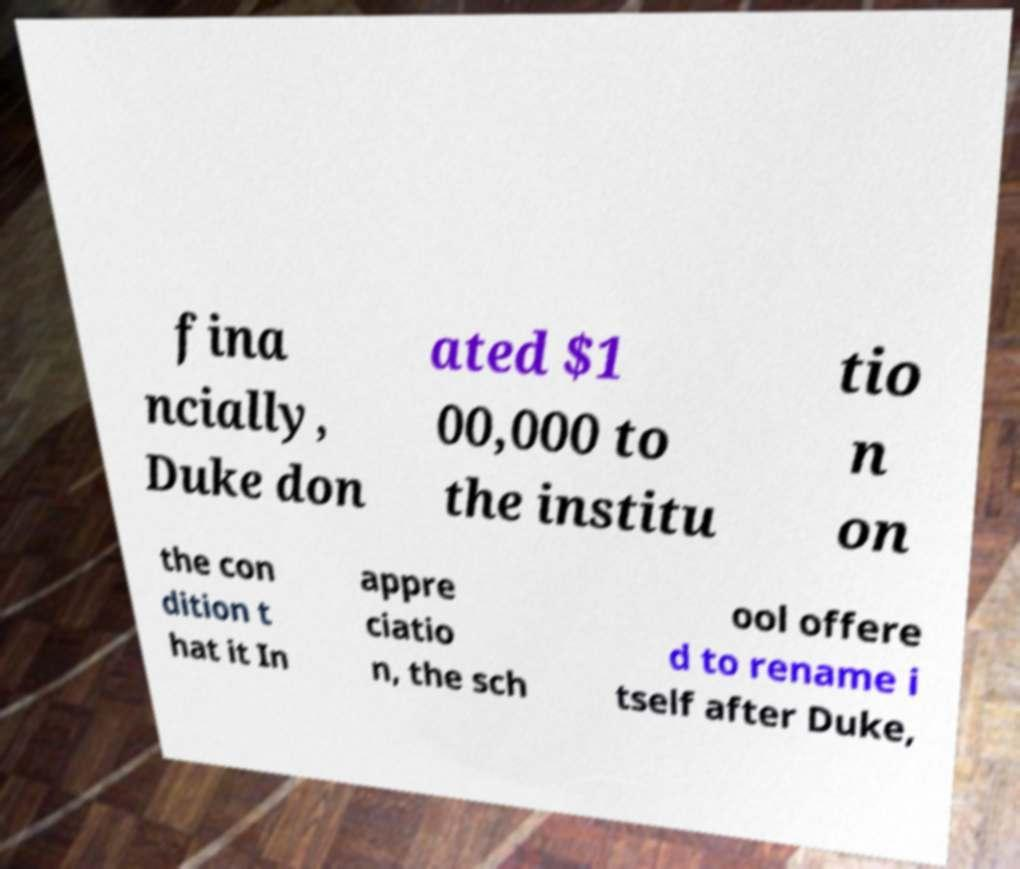Could you assist in decoding the text presented in this image and type it out clearly? fina ncially, Duke don ated $1 00,000 to the institu tio n on the con dition t hat it In appre ciatio n, the sch ool offere d to rename i tself after Duke, 